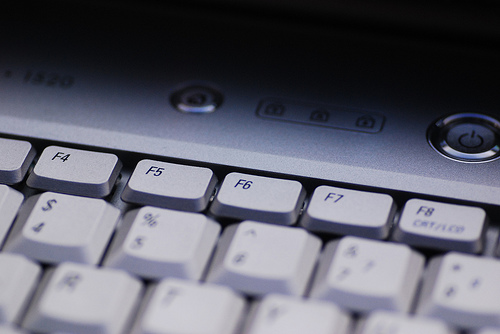<image>
Is there a key in the laptop? Yes. The key is contained within or inside the laptop, showing a containment relationship. 